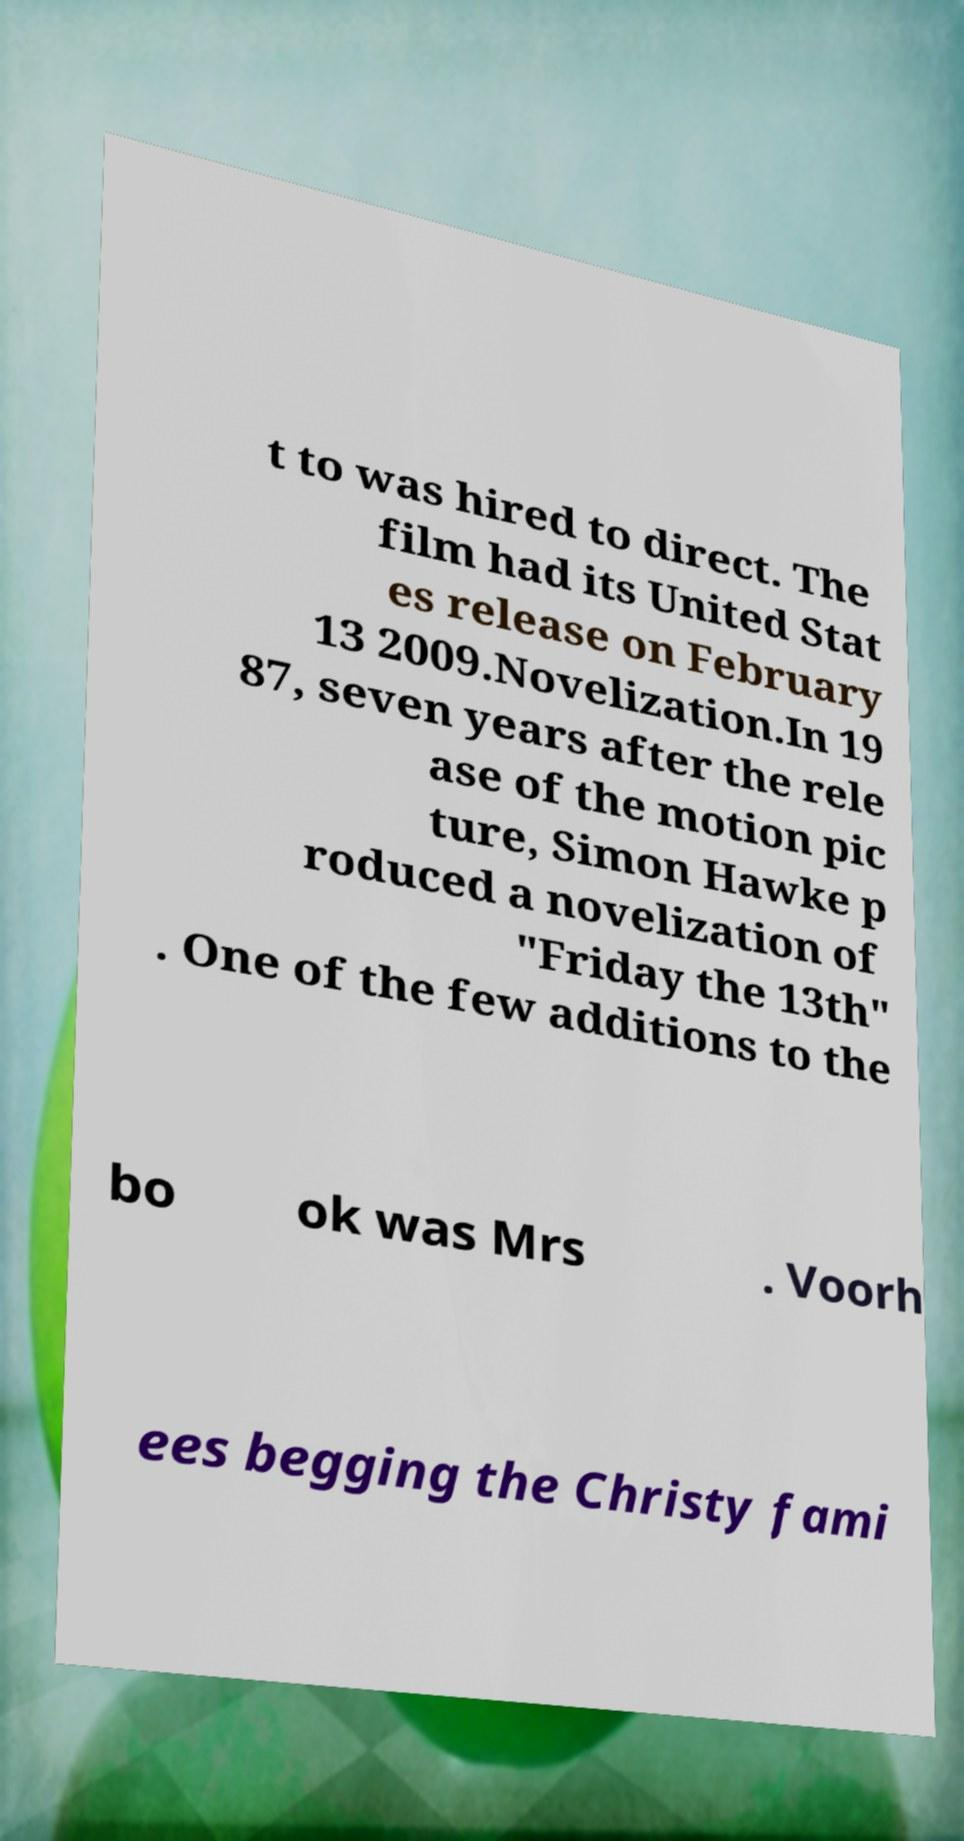I need the written content from this picture converted into text. Can you do that? t to was hired to direct. The film had its United Stat es release on February 13 2009.Novelization.In 19 87, seven years after the rele ase of the motion pic ture, Simon Hawke p roduced a novelization of "Friday the 13th" . One of the few additions to the bo ok was Mrs . Voorh ees begging the Christy fami 